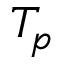<formula> <loc_0><loc_0><loc_500><loc_500>T _ { p }</formula> 